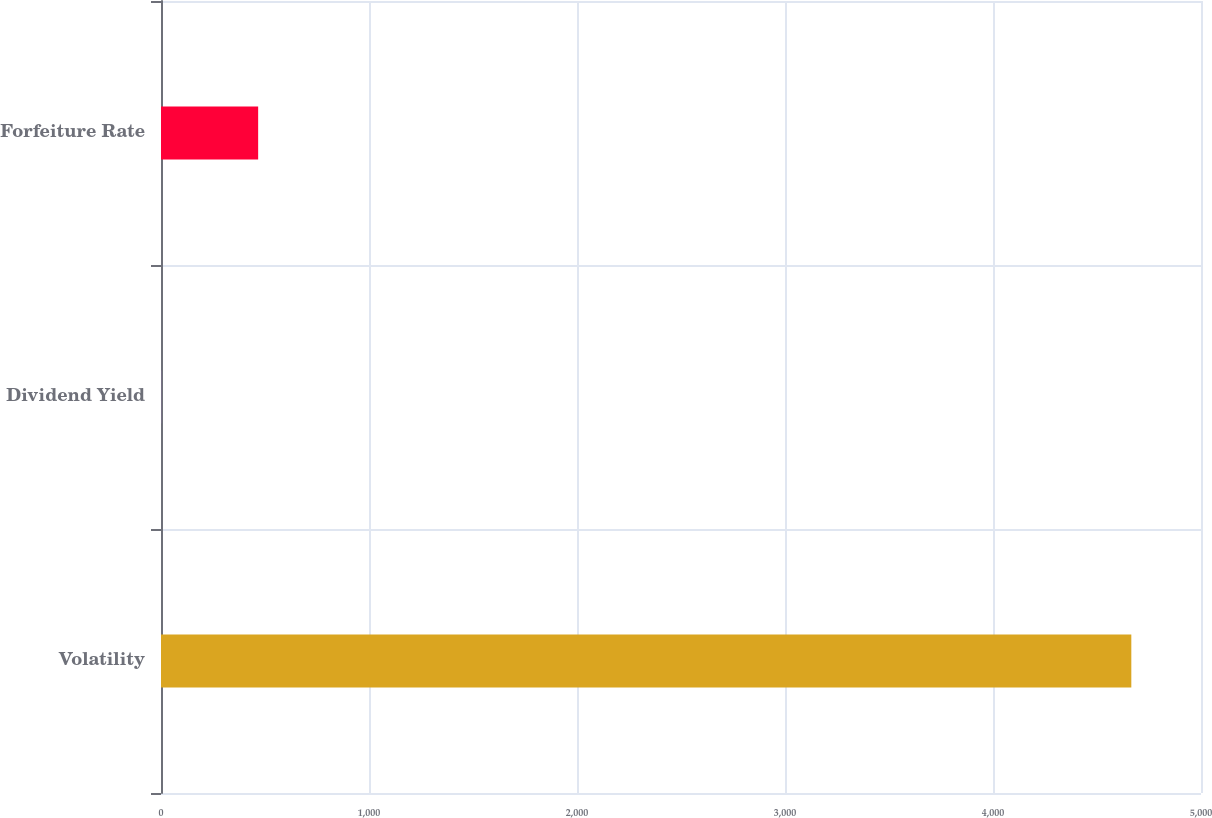Convert chart. <chart><loc_0><loc_0><loc_500><loc_500><bar_chart><fcel>Volatility<fcel>Dividend Yield<fcel>Forfeiture Rate<nl><fcel>4665<fcel>0.65<fcel>467.09<nl></chart> 